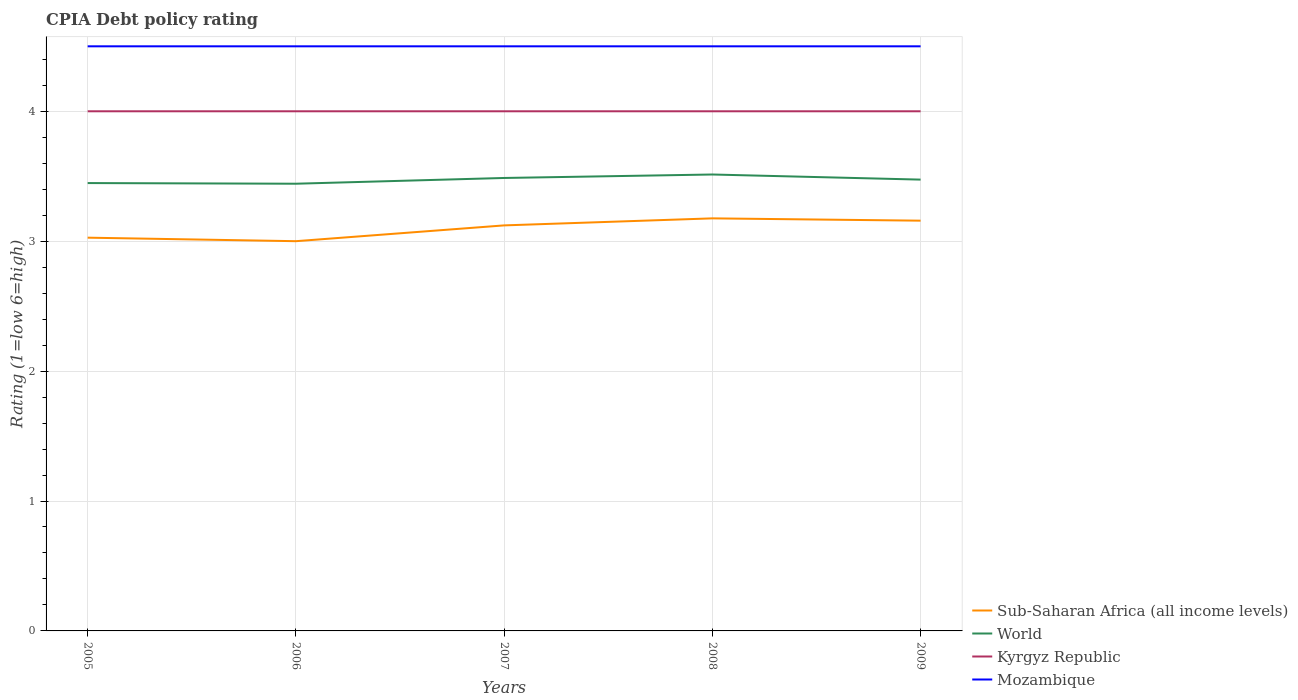Across all years, what is the maximum CPIA rating in Kyrgyz Republic?
Make the answer very short. 4. In which year was the CPIA rating in Kyrgyz Republic maximum?
Ensure brevity in your answer.  2005. What is the total CPIA rating in World in the graph?
Offer a terse response. -0.03. What is the difference between the highest and the second highest CPIA rating in Kyrgyz Republic?
Your answer should be compact. 0. What is the difference between the highest and the lowest CPIA rating in Kyrgyz Republic?
Offer a terse response. 0. How many lines are there?
Offer a terse response. 4. Does the graph contain any zero values?
Your answer should be very brief. No. Where does the legend appear in the graph?
Keep it short and to the point. Bottom right. What is the title of the graph?
Your answer should be very brief. CPIA Debt policy rating. What is the label or title of the X-axis?
Keep it short and to the point. Years. What is the label or title of the Y-axis?
Make the answer very short. Rating (1=low 6=high). What is the Rating (1=low 6=high) of Sub-Saharan Africa (all income levels) in 2005?
Keep it short and to the point. 3.03. What is the Rating (1=low 6=high) in World in 2005?
Your answer should be compact. 3.45. What is the Rating (1=low 6=high) in Mozambique in 2005?
Provide a succinct answer. 4.5. What is the Rating (1=low 6=high) of Sub-Saharan Africa (all income levels) in 2006?
Make the answer very short. 3. What is the Rating (1=low 6=high) in World in 2006?
Provide a succinct answer. 3.44. What is the Rating (1=low 6=high) of Sub-Saharan Africa (all income levels) in 2007?
Your answer should be very brief. 3.12. What is the Rating (1=low 6=high) in World in 2007?
Make the answer very short. 3.49. What is the Rating (1=low 6=high) of Mozambique in 2007?
Keep it short and to the point. 4.5. What is the Rating (1=low 6=high) in Sub-Saharan Africa (all income levels) in 2008?
Offer a very short reply. 3.18. What is the Rating (1=low 6=high) in World in 2008?
Offer a terse response. 3.51. What is the Rating (1=low 6=high) of Sub-Saharan Africa (all income levels) in 2009?
Give a very brief answer. 3.16. What is the Rating (1=low 6=high) in World in 2009?
Offer a terse response. 3.47. What is the Rating (1=low 6=high) in Mozambique in 2009?
Provide a short and direct response. 4.5. Across all years, what is the maximum Rating (1=low 6=high) in Sub-Saharan Africa (all income levels)?
Offer a terse response. 3.18. Across all years, what is the maximum Rating (1=low 6=high) in World?
Offer a terse response. 3.51. Across all years, what is the maximum Rating (1=low 6=high) in Kyrgyz Republic?
Your answer should be very brief. 4. Across all years, what is the maximum Rating (1=low 6=high) of Mozambique?
Ensure brevity in your answer.  4.5. Across all years, what is the minimum Rating (1=low 6=high) of World?
Keep it short and to the point. 3.44. Across all years, what is the minimum Rating (1=low 6=high) in Kyrgyz Republic?
Keep it short and to the point. 4. What is the total Rating (1=low 6=high) in Sub-Saharan Africa (all income levels) in the graph?
Provide a succinct answer. 15.48. What is the total Rating (1=low 6=high) in World in the graph?
Make the answer very short. 17.36. What is the total Rating (1=low 6=high) in Mozambique in the graph?
Provide a succinct answer. 22.5. What is the difference between the Rating (1=low 6=high) in Sub-Saharan Africa (all income levels) in 2005 and that in 2006?
Keep it short and to the point. 0.03. What is the difference between the Rating (1=low 6=high) of World in 2005 and that in 2006?
Provide a succinct answer. 0.01. What is the difference between the Rating (1=low 6=high) in Sub-Saharan Africa (all income levels) in 2005 and that in 2007?
Your answer should be compact. -0.09. What is the difference between the Rating (1=low 6=high) in World in 2005 and that in 2007?
Make the answer very short. -0.04. What is the difference between the Rating (1=low 6=high) of Sub-Saharan Africa (all income levels) in 2005 and that in 2008?
Ensure brevity in your answer.  -0.15. What is the difference between the Rating (1=low 6=high) of World in 2005 and that in 2008?
Provide a succinct answer. -0.07. What is the difference between the Rating (1=low 6=high) of Kyrgyz Republic in 2005 and that in 2008?
Keep it short and to the point. 0. What is the difference between the Rating (1=low 6=high) in Mozambique in 2005 and that in 2008?
Offer a terse response. 0. What is the difference between the Rating (1=low 6=high) of Sub-Saharan Africa (all income levels) in 2005 and that in 2009?
Offer a terse response. -0.13. What is the difference between the Rating (1=low 6=high) of World in 2005 and that in 2009?
Your answer should be very brief. -0.03. What is the difference between the Rating (1=low 6=high) in Sub-Saharan Africa (all income levels) in 2006 and that in 2007?
Provide a succinct answer. -0.12. What is the difference between the Rating (1=low 6=high) in World in 2006 and that in 2007?
Offer a very short reply. -0.04. What is the difference between the Rating (1=low 6=high) in Kyrgyz Republic in 2006 and that in 2007?
Your response must be concise. 0. What is the difference between the Rating (1=low 6=high) of Mozambique in 2006 and that in 2007?
Provide a short and direct response. 0. What is the difference between the Rating (1=low 6=high) of Sub-Saharan Africa (all income levels) in 2006 and that in 2008?
Your answer should be compact. -0.18. What is the difference between the Rating (1=low 6=high) in World in 2006 and that in 2008?
Offer a terse response. -0.07. What is the difference between the Rating (1=low 6=high) in Mozambique in 2006 and that in 2008?
Give a very brief answer. 0. What is the difference between the Rating (1=low 6=high) of Sub-Saharan Africa (all income levels) in 2006 and that in 2009?
Your answer should be very brief. -0.16. What is the difference between the Rating (1=low 6=high) in World in 2006 and that in 2009?
Keep it short and to the point. -0.03. What is the difference between the Rating (1=low 6=high) in Sub-Saharan Africa (all income levels) in 2007 and that in 2008?
Your response must be concise. -0.05. What is the difference between the Rating (1=low 6=high) in World in 2007 and that in 2008?
Provide a short and direct response. -0.03. What is the difference between the Rating (1=low 6=high) of Kyrgyz Republic in 2007 and that in 2008?
Provide a succinct answer. 0. What is the difference between the Rating (1=low 6=high) in Mozambique in 2007 and that in 2008?
Offer a very short reply. 0. What is the difference between the Rating (1=low 6=high) in Sub-Saharan Africa (all income levels) in 2007 and that in 2009?
Provide a short and direct response. -0.04. What is the difference between the Rating (1=low 6=high) in World in 2007 and that in 2009?
Your response must be concise. 0.01. What is the difference between the Rating (1=low 6=high) of Kyrgyz Republic in 2007 and that in 2009?
Keep it short and to the point. 0. What is the difference between the Rating (1=low 6=high) of Mozambique in 2007 and that in 2009?
Keep it short and to the point. 0. What is the difference between the Rating (1=low 6=high) in Sub-Saharan Africa (all income levels) in 2008 and that in 2009?
Provide a short and direct response. 0.02. What is the difference between the Rating (1=low 6=high) of World in 2008 and that in 2009?
Provide a succinct answer. 0.04. What is the difference between the Rating (1=low 6=high) of Mozambique in 2008 and that in 2009?
Ensure brevity in your answer.  0. What is the difference between the Rating (1=low 6=high) in Sub-Saharan Africa (all income levels) in 2005 and the Rating (1=low 6=high) in World in 2006?
Your response must be concise. -0.42. What is the difference between the Rating (1=low 6=high) in Sub-Saharan Africa (all income levels) in 2005 and the Rating (1=low 6=high) in Kyrgyz Republic in 2006?
Your answer should be compact. -0.97. What is the difference between the Rating (1=low 6=high) in Sub-Saharan Africa (all income levels) in 2005 and the Rating (1=low 6=high) in Mozambique in 2006?
Your answer should be very brief. -1.47. What is the difference between the Rating (1=low 6=high) in World in 2005 and the Rating (1=low 6=high) in Kyrgyz Republic in 2006?
Your answer should be compact. -0.55. What is the difference between the Rating (1=low 6=high) in World in 2005 and the Rating (1=low 6=high) in Mozambique in 2006?
Offer a very short reply. -1.05. What is the difference between the Rating (1=low 6=high) of Kyrgyz Republic in 2005 and the Rating (1=low 6=high) of Mozambique in 2006?
Your answer should be compact. -0.5. What is the difference between the Rating (1=low 6=high) in Sub-Saharan Africa (all income levels) in 2005 and the Rating (1=low 6=high) in World in 2007?
Your answer should be compact. -0.46. What is the difference between the Rating (1=low 6=high) of Sub-Saharan Africa (all income levels) in 2005 and the Rating (1=low 6=high) of Kyrgyz Republic in 2007?
Provide a short and direct response. -0.97. What is the difference between the Rating (1=low 6=high) in Sub-Saharan Africa (all income levels) in 2005 and the Rating (1=low 6=high) in Mozambique in 2007?
Make the answer very short. -1.47. What is the difference between the Rating (1=low 6=high) of World in 2005 and the Rating (1=low 6=high) of Kyrgyz Republic in 2007?
Offer a terse response. -0.55. What is the difference between the Rating (1=low 6=high) of World in 2005 and the Rating (1=low 6=high) of Mozambique in 2007?
Your answer should be compact. -1.05. What is the difference between the Rating (1=low 6=high) in Kyrgyz Republic in 2005 and the Rating (1=low 6=high) in Mozambique in 2007?
Offer a very short reply. -0.5. What is the difference between the Rating (1=low 6=high) in Sub-Saharan Africa (all income levels) in 2005 and the Rating (1=low 6=high) in World in 2008?
Provide a short and direct response. -0.49. What is the difference between the Rating (1=low 6=high) of Sub-Saharan Africa (all income levels) in 2005 and the Rating (1=low 6=high) of Kyrgyz Republic in 2008?
Provide a succinct answer. -0.97. What is the difference between the Rating (1=low 6=high) of Sub-Saharan Africa (all income levels) in 2005 and the Rating (1=low 6=high) of Mozambique in 2008?
Make the answer very short. -1.47. What is the difference between the Rating (1=low 6=high) of World in 2005 and the Rating (1=low 6=high) of Kyrgyz Republic in 2008?
Offer a very short reply. -0.55. What is the difference between the Rating (1=low 6=high) in World in 2005 and the Rating (1=low 6=high) in Mozambique in 2008?
Your response must be concise. -1.05. What is the difference between the Rating (1=low 6=high) of Kyrgyz Republic in 2005 and the Rating (1=low 6=high) of Mozambique in 2008?
Provide a short and direct response. -0.5. What is the difference between the Rating (1=low 6=high) of Sub-Saharan Africa (all income levels) in 2005 and the Rating (1=low 6=high) of World in 2009?
Give a very brief answer. -0.45. What is the difference between the Rating (1=low 6=high) in Sub-Saharan Africa (all income levels) in 2005 and the Rating (1=low 6=high) in Kyrgyz Republic in 2009?
Your response must be concise. -0.97. What is the difference between the Rating (1=low 6=high) in Sub-Saharan Africa (all income levels) in 2005 and the Rating (1=low 6=high) in Mozambique in 2009?
Offer a very short reply. -1.47. What is the difference between the Rating (1=low 6=high) in World in 2005 and the Rating (1=low 6=high) in Kyrgyz Republic in 2009?
Ensure brevity in your answer.  -0.55. What is the difference between the Rating (1=low 6=high) of World in 2005 and the Rating (1=low 6=high) of Mozambique in 2009?
Make the answer very short. -1.05. What is the difference between the Rating (1=low 6=high) in Sub-Saharan Africa (all income levels) in 2006 and the Rating (1=low 6=high) in World in 2007?
Give a very brief answer. -0.49. What is the difference between the Rating (1=low 6=high) in World in 2006 and the Rating (1=low 6=high) in Kyrgyz Republic in 2007?
Make the answer very short. -0.56. What is the difference between the Rating (1=low 6=high) of World in 2006 and the Rating (1=low 6=high) of Mozambique in 2007?
Your response must be concise. -1.06. What is the difference between the Rating (1=low 6=high) of Sub-Saharan Africa (all income levels) in 2006 and the Rating (1=low 6=high) of World in 2008?
Give a very brief answer. -0.51. What is the difference between the Rating (1=low 6=high) of World in 2006 and the Rating (1=low 6=high) of Kyrgyz Republic in 2008?
Keep it short and to the point. -0.56. What is the difference between the Rating (1=low 6=high) in World in 2006 and the Rating (1=low 6=high) in Mozambique in 2008?
Ensure brevity in your answer.  -1.06. What is the difference between the Rating (1=low 6=high) of Kyrgyz Republic in 2006 and the Rating (1=low 6=high) of Mozambique in 2008?
Your response must be concise. -0.5. What is the difference between the Rating (1=low 6=high) of Sub-Saharan Africa (all income levels) in 2006 and the Rating (1=low 6=high) of World in 2009?
Offer a very short reply. -0.47. What is the difference between the Rating (1=low 6=high) in World in 2006 and the Rating (1=low 6=high) in Kyrgyz Republic in 2009?
Ensure brevity in your answer.  -0.56. What is the difference between the Rating (1=low 6=high) of World in 2006 and the Rating (1=low 6=high) of Mozambique in 2009?
Offer a terse response. -1.06. What is the difference between the Rating (1=low 6=high) of Kyrgyz Republic in 2006 and the Rating (1=low 6=high) of Mozambique in 2009?
Your answer should be compact. -0.5. What is the difference between the Rating (1=low 6=high) in Sub-Saharan Africa (all income levels) in 2007 and the Rating (1=low 6=high) in World in 2008?
Your answer should be very brief. -0.39. What is the difference between the Rating (1=low 6=high) of Sub-Saharan Africa (all income levels) in 2007 and the Rating (1=low 6=high) of Kyrgyz Republic in 2008?
Offer a very short reply. -0.88. What is the difference between the Rating (1=low 6=high) of Sub-Saharan Africa (all income levels) in 2007 and the Rating (1=low 6=high) of Mozambique in 2008?
Keep it short and to the point. -1.38. What is the difference between the Rating (1=low 6=high) of World in 2007 and the Rating (1=low 6=high) of Kyrgyz Republic in 2008?
Your response must be concise. -0.51. What is the difference between the Rating (1=low 6=high) in World in 2007 and the Rating (1=low 6=high) in Mozambique in 2008?
Provide a succinct answer. -1.01. What is the difference between the Rating (1=low 6=high) of Kyrgyz Republic in 2007 and the Rating (1=low 6=high) of Mozambique in 2008?
Your answer should be very brief. -0.5. What is the difference between the Rating (1=low 6=high) of Sub-Saharan Africa (all income levels) in 2007 and the Rating (1=low 6=high) of World in 2009?
Offer a terse response. -0.35. What is the difference between the Rating (1=low 6=high) of Sub-Saharan Africa (all income levels) in 2007 and the Rating (1=low 6=high) of Kyrgyz Republic in 2009?
Give a very brief answer. -0.88. What is the difference between the Rating (1=low 6=high) in Sub-Saharan Africa (all income levels) in 2007 and the Rating (1=low 6=high) in Mozambique in 2009?
Provide a short and direct response. -1.38. What is the difference between the Rating (1=low 6=high) in World in 2007 and the Rating (1=low 6=high) in Kyrgyz Republic in 2009?
Offer a very short reply. -0.51. What is the difference between the Rating (1=low 6=high) in World in 2007 and the Rating (1=low 6=high) in Mozambique in 2009?
Ensure brevity in your answer.  -1.01. What is the difference between the Rating (1=low 6=high) in Kyrgyz Republic in 2007 and the Rating (1=low 6=high) in Mozambique in 2009?
Make the answer very short. -0.5. What is the difference between the Rating (1=low 6=high) of Sub-Saharan Africa (all income levels) in 2008 and the Rating (1=low 6=high) of World in 2009?
Your response must be concise. -0.3. What is the difference between the Rating (1=low 6=high) of Sub-Saharan Africa (all income levels) in 2008 and the Rating (1=low 6=high) of Kyrgyz Republic in 2009?
Give a very brief answer. -0.82. What is the difference between the Rating (1=low 6=high) in Sub-Saharan Africa (all income levels) in 2008 and the Rating (1=low 6=high) in Mozambique in 2009?
Keep it short and to the point. -1.32. What is the difference between the Rating (1=low 6=high) of World in 2008 and the Rating (1=low 6=high) of Kyrgyz Republic in 2009?
Make the answer very short. -0.49. What is the difference between the Rating (1=low 6=high) in World in 2008 and the Rating (1=low 6=high) in Mozambique in 2009?
Offer a terse response. -0.99. What is the difference between the Rating (1=low 6=high) of Kyrgyz Republic in 2008 and the Rating (1=low 6=high) of Mozambique in 2009?
Offer a terse response. -0.5. What is the average Rating (1=low 6=high) in Sub-Saharan Africa (all income levels) per year?
Offer a terse response. 3.1. What is the average Rating (1=low 6=high) of World per year?
Provide a succinct answer. 3.47. In the year 2005, what is the difference between the Rating (1=low 6=high) in Sub-Saharan Africa (all income levels) and Rating (1=low 6=high) in World?
Offer a very short reply. -0.42. In the year 2005, what is the difference between the Rating (1=low 6=high) in Sub-Saharan Africa (all income levels) and Rating (1=low 6=high) in Kyrgyz Republic?
Provide a succinct answer. -0.97. In the year 2005, what is the difference between the Rating (1=low 6=high) of Sub-Saharan Africa (all income levels) and Rating (1=low 6=high) of Mozambique?
Provide a short and direct response. -1.47. In the year 2005, what is the difference between the Rating (1=low 6=high) in World and Rating (1=low 6=high) in Kyrgyz Republic?
Offer a very short reply. -0.55. In the year 2005, what is the difference between the Rating (1=low 6=high) in World and Rating (1=low 6=high) in Mozambique?
Offer a terse response. -1.05. In the year 2005, what is the difference between the Rating (1=low 6=high) in Kyrgyz Republic and Rating (1=low 6=high) in Mozambique?
Keep it short and to the point. -0.5. In the year 2006, what is the difference between the Rating (1=low 6=high) of Sub-Saharan Africa (all income levels) and Rating (1=low 6=high) of World?
Offer a terse response. -0.44. In the year 2006, what is the difference between the Rating (1=low 6=high) of Sub-Saharan Africa (all income levels) and Rating (1=low 6=high) of Mozambique?
Your answer should be very brief. -1.5. In the year 2006, what is the difference between the Rating (1=low 6=high) in World and Rating (1=low 6=high) in Kyrgyz Republic?
Your response must be concise. -0.56. In the year 2006, what is the difference between the Rating (1=low 6=high) of World and Rating (1=low 6=high) of Mozambique?
Ensure brevity in your answer.  -1.06. In the year 2006, what is the difference between the Rating (1=low 6=high) of Kyrgyz Republic and Rating (1=low 6=high) of Mozambique?
Keep it short and to the point. -0.5. In the year 2007, what is the difference between the Rating (1=low 6=high) in Sub-Saharan Africa (all income levels) and Rating (1=low 6=high) in World?
Provide a short and direct response. -0.36. In the year 2007, what is the difference between the Rating (1=low 6=high) of Sub-Saharan Africa (all income levels) and Rating (1=low 6=high) of Kyrgyz Republic?
Give a very brief answer. -0.88. In the year 2007, what is the difference between the Rating (1=low 6=high) of Sub-Saharan Africa (all income levels) and Rating (1=low 6=high) of Mozambique?
Keep it short and to the point. -1.38. In the year 2007, what is the difference between the Rating (1=low 6=high) of World and Rating (1=low 6=high) of Kyrgyz Republic?
Make the answer very short. -0.51. In the year 2007, what is the difference between the Rating (1=low 6=high) of World and Rating (1=low 6=high) of Mozambique?
Give a very brief answer. -1.01. In the year 2008, what is the difference between the Rating (1=low 6=high) of Sub-Saharan Africa (all income levels) and Rating (1=low 6=high) of World?
Provide a succinct answer. -0.34. In the year 2008, what is the difference between the Rating (1=low 6=high) of Sub-Saharan Africa (all income levels) and Rating (1=low 6=high) of Kyrgyz Republic?
Your response must be concise. -0.82. In the year 2008, what is the difference between the Rating (1=low 6=high) of Sub-Saharan Africa (all income levels) and Rating (1=low 6=high) of Mozambique?
Provide a succinct answer. -1.32. In the year 2008, what is the difference between the Rating (1=low 6=high) of World and Rating (1=low 6=high) of Kyrgyz Republic?
Give a very brief answer. -0.49. In the year 2008, what is the difference between the Rating (1=low 6=high) in World and Rating (1=low 6=high) in Mozambique?
Make the answer very short. -0.99. In the year 2009, what is the difference between the Rating (1=low 6=high) of Sub-Saharan Africa (all income levels) and Rating (1=low 6=high) of World?
Keep it short and to the point. -0.32. In the year 2009, what is the difference between the Rating (1=low 6=high) of Sub-Saharan Africa (all income levels) and Rating (1=low 6=high) of Kyrgyz Republic?
Your response must be concise. -0.84. In the year 2009, what is the difference between the Rating (1=low 6=high) of Sub-Saharan Africa (all income levels) and Rating (1=low 6=high) of Mozambique?
Provide a succinct answer. -1.34. In the year 2009, what is the difference between the Rating (1=low 6=high) in World and Rating (1=low 6=high) in Kyrgyz Republic?
Offer a terse response. -0.53. In the year 2009, what is the difference between the Rating (1=low 6=high) of World and Rating (1=low 6=high) of Mozambique?
Offer a terse response. -1.03. What is the ratio of the Rating (1=low 6=high) of Mozambique in 2005 to that in 2006?
Keep it short and to the point. 1. What is the ratio of the Rating (1=low 6=high) of Sub-Saharan Africa (all income levels) in 2005 to that in 2007?
Offer a terse response. 0.97. What is the ratio of the Rating (1=low 6=high) in World in 2005 to that in 2007?
Make the answer very short. 0.99. What is the ratio of the Rating (1=low 6=high) in Kyrgyz Republic in 2005 to that in 2007?
Provide a short and direct response. 1. What is the ratio of the Rating (1=low 6=high) in Mozambique in 2005 to that in 2007?
Provide a succinct answer. 1. What is the ratio of the Rating (1=low 6=high) in Sub-Saharan Africa (all income levels) in 2005 to that in 2008?
Give a very brief answer. 0.95. What is the ratio of the Rating (1=low 6=high) in World in 2005 to that in 2008?
Provide a short and direct response. 0.98. What is the ratio of the Rating (1=low 6=high) of Kyrgyz Republic in 2005 to that in 2008?
Offer a terse response. 1. What is the ratio of the Rating (1=low 6=high) of Mozambique in 2005 to that in 2008?
Your answer should be very brief. 1. What is the ratio of the Rating (1=low 6=high) of Sub-Saharan Africa (all income levels) in 2005 to that in 2009?
Your answer should be compact. 0.96. What is the ratio of the Rating (1=low 6=high) in Kyrgyz Republic in 2005 to that in 2009?
Ensure brevity in your answer.  1. What is the ratio of the Rating (1=low 6=high) in Mozambique in 2005 to that in 2009?
Your answer should be very brief. 1. What is the ratio of the Rating (1=low 6=high) in Sub-Saharan Africa (all income levels) in 2006 to that in 2007?
Your response must be concise. 0.96. What is the ratio of the Rating (1=low 6=high) of World in 2006 to that in 2007?
Offer a very short reply. 0.99. What is the ratio of the Rating (1=low 6=high) in Sub-Saharan Africa (all income levels) in 2006 to that in 2008?
Your answer should be compact. 0.94. What is the ratio of the Rating (1=low 6=high) in World in 2006 to that in 2008?
Your response must be concise. 0.98. What is the ratio of the Rating (1=low 6=high) of Kyrgyz Republic in 2006 to that in 2008?
Give a very brief answer. 1. What is the ratio of the Rating (1=low 6=high) of Sub-Saharan Africa (all income levels) in 2006 to that in 2009?
Make the answer very short. 0.95. What is the ratio of the Rating (1=low 6=high) in World in 2006 to that in 2009?
Your response must be concise. 0.99. What is the ratio of the Rating (1=low 6=high) of Sub-Saharan Africa (all income levels) in 2007 to that in 2008?
Make the answer very short. 0.98. What is the ratio of the Rating (1=low 6=high) of World in 2007 to that in 2008?
Provide a succinct answer. 0.99. What is the ratio of the Rating (1=low 6=high) of Sub-Saharan Africa (all income levels) in 2007 to that in 2009?
Your answer should be very brief. 0.99. What is the ratio of the Rating (1=low 6=high) of Kyrgyz Republic in 2007 to that in 2009?
Offer a very short reply. 1. What is the ratio of the Rating (1=low 6=high) of Sub-Saharan Africa (all income levels) in 2008 to that in 2009?
Provide a succinct answer. 1.01. What is the ratio of the Rating (1=low 6=high) in World in 2008 to that in 2009?
Your answer should be compact. 1.01. What is the difference between the highest and the second highest Rating (1=low 6=high) in Sub-Saharan Africa (all income levels)?
Provide a short and direct response. 0.02. What is the difference between the highest and the second highest Rating (1=low 6=high) of World?
Your answer should be compact. 0.03. What is the difference between the highest and the lowest Rating (1=low 6=high) in Sub-Saharan Africa (all income levels)?
Offer a very short reply. 0.18. What is the difference between the highest and the lowest Rating (1=low 6=high) in World?
Your answer should be very brief. 0.07. What is the difference between the highest and the lowest Rating (1=low 6=high) of Kyrgyz Republic?
Your response must be concise. 0. What is the difference between the highest and the lowest Rating (1=low 6=high) of Mozambique?
Your answer should be very brief. 0. 